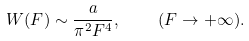Convert formula to latex. <formula><loc_0><loc_0><loc_500><loc_500>W ( { F } ) \sim \frac { a } { \pi ^ { 2 } F ^ { 4 } } , \quad ( F \rightarrow + \infty ) .</formula> 